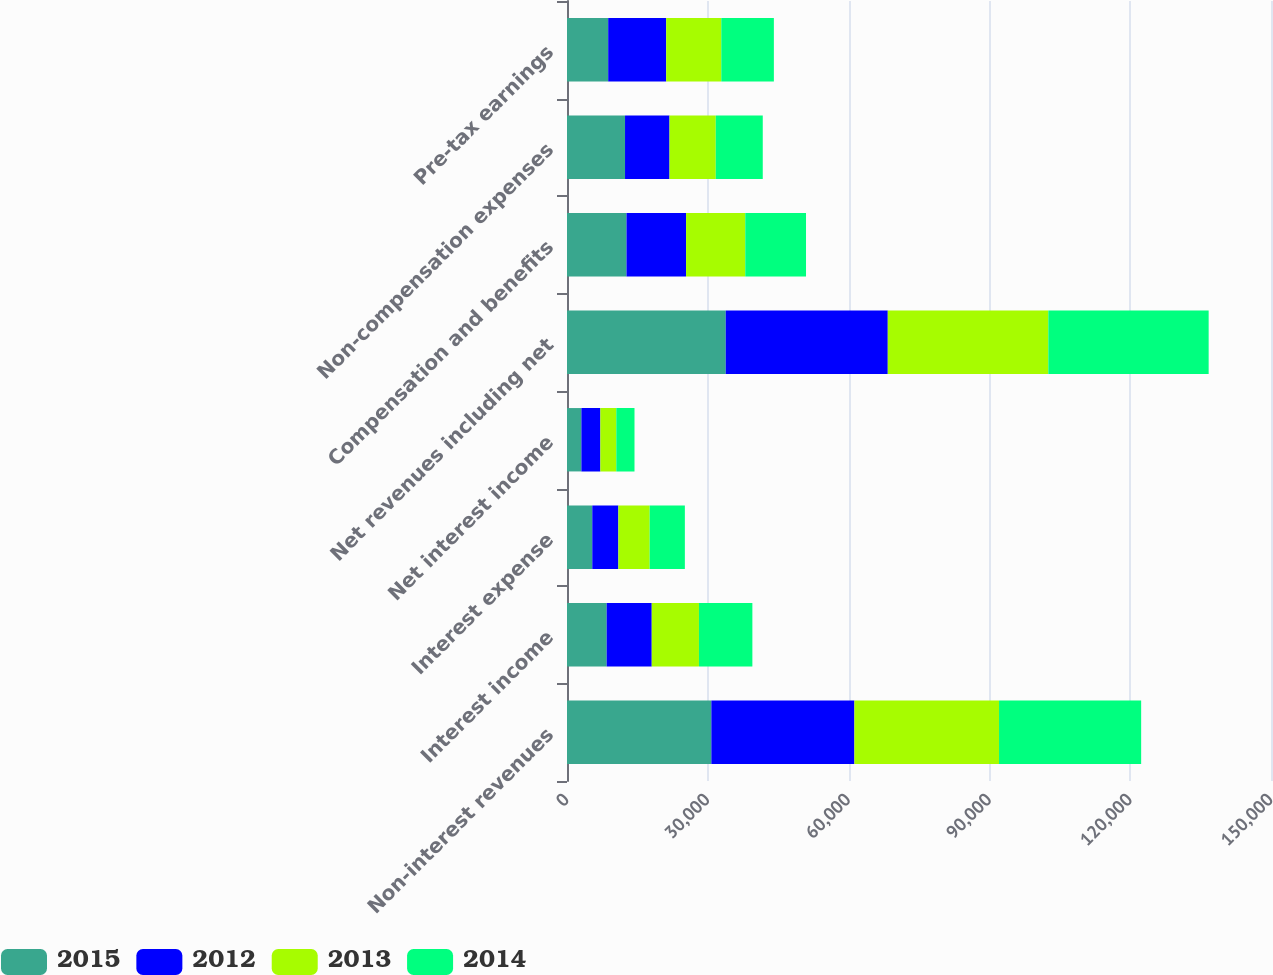Convert chart. <chart><loc_0><loc_0><loc_500><loc_500><stacked_bar_chart><ecel><fcel>Non-interest revenues<fcel>Interest income<fcel>Interest expense<fcel>Net interest income<fcel>Net revenues including net<fcel>Compensation and benefits<fcel>Non-compensation expenses<fcel>Pre-tax earnings<nl><fcel>2015<fcel>30756<fcel>8452<fcel>5388<fcel>3064<fcel>33820<fcel>12678<fcel>12364<fcel>8778<nl><fcel>2012<fcel>30481<fcel>9604<fcel>5557<fcel>4047<fcel>34528<fcel>12691<fcel>9480<fcel>12357<nl><fcel>2013<fcel>30814<fcel>10060<fcel>6668<fcel>3392<fcel>34206<fcel>12613<fcel>9856<fcel>11737<nl><fcel>2014<fcel>30283<fcel>11381<fcel>7501<fcel>3880<fcel>34163<fcel>12944<fcel>10012<fcel>11207<nl></chart> 